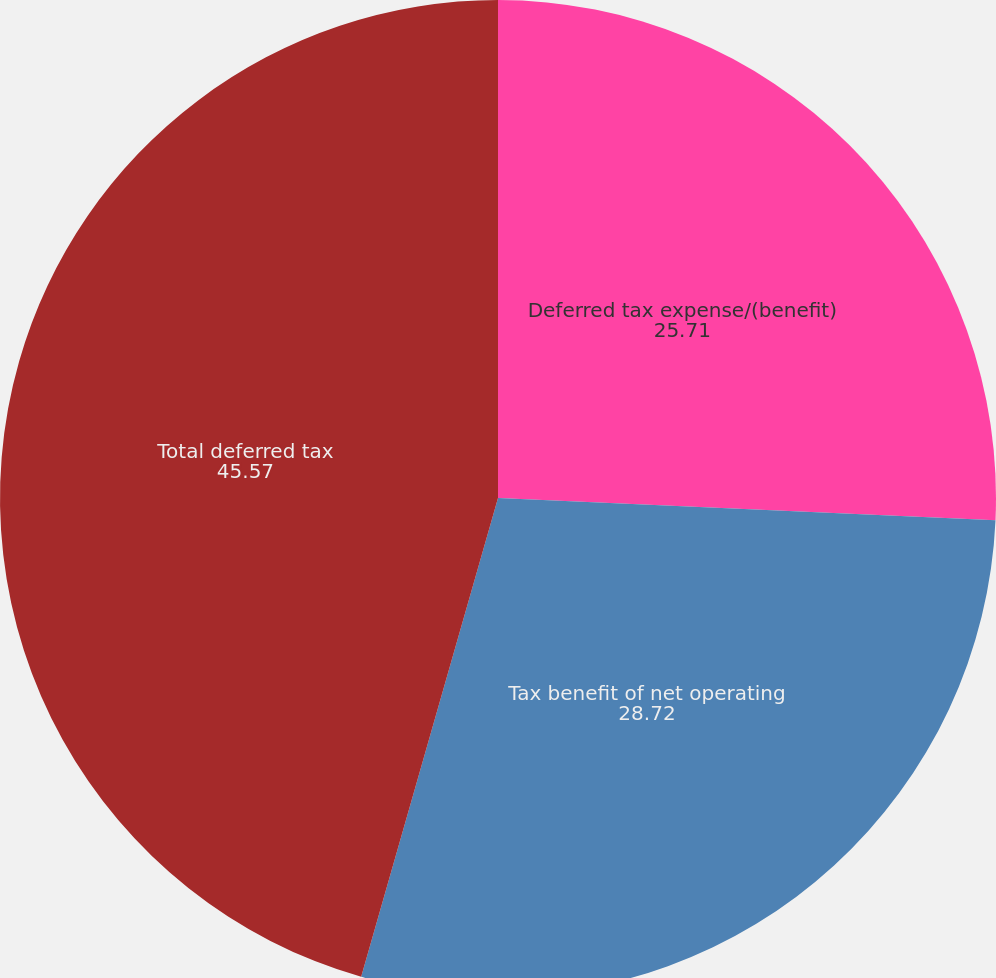Convert chart. <chart><loc_0><loc_0><loc_500><loc_500><pie_chart><fcel>Deferred tax expense/(benefit)<fcel>Tax benefit of net operating<fcel>Total deferred tax<nl><fcel>25.71%<fcel>28.72%<fcel>45.57%<nl></chart> 